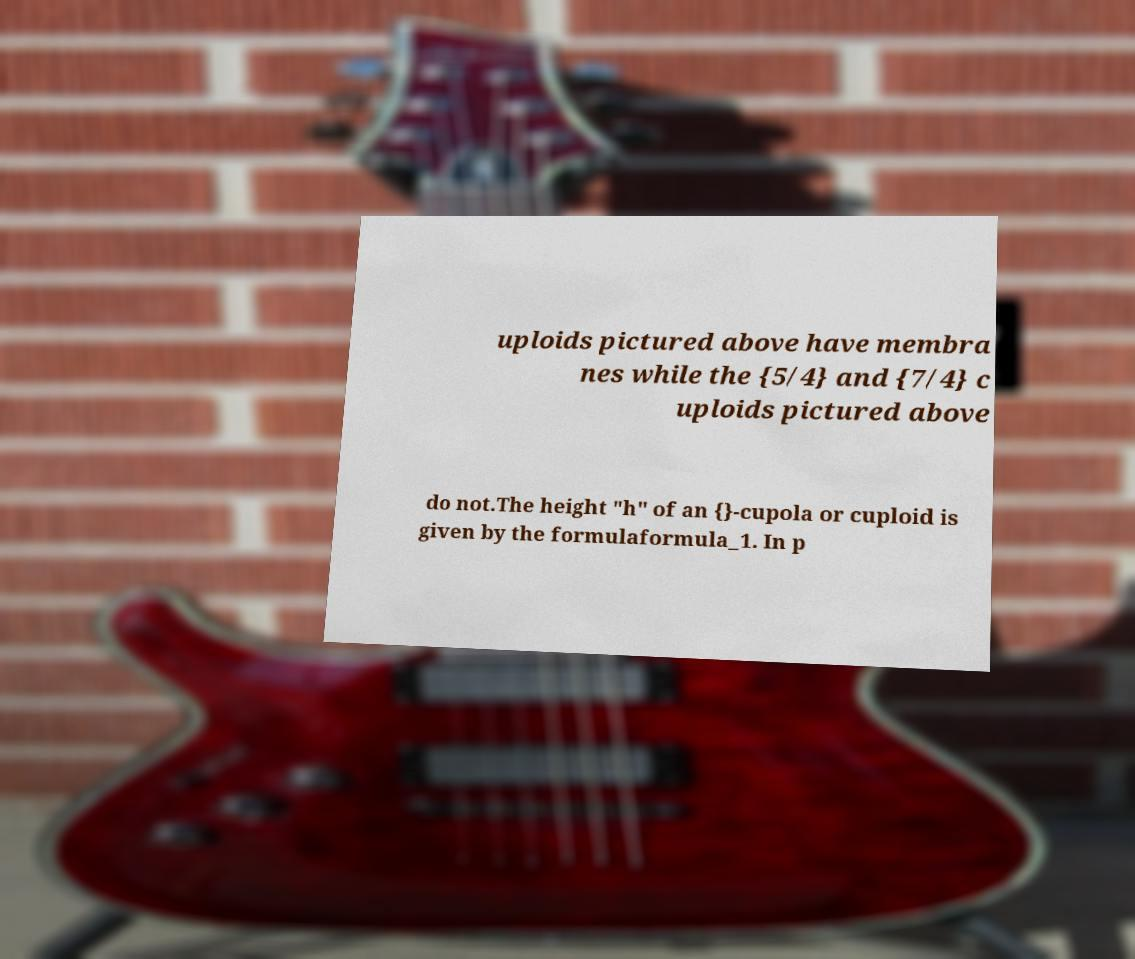There's text embedded in this image that I need extracted. Can you transcribe it verbatim? uploids pictured above have membra nes while the {5/4} and {7/4} c uploids pictured above do not.The height "h" of an {}-cupola or cuploid is given by the formulaformula_1. In p 